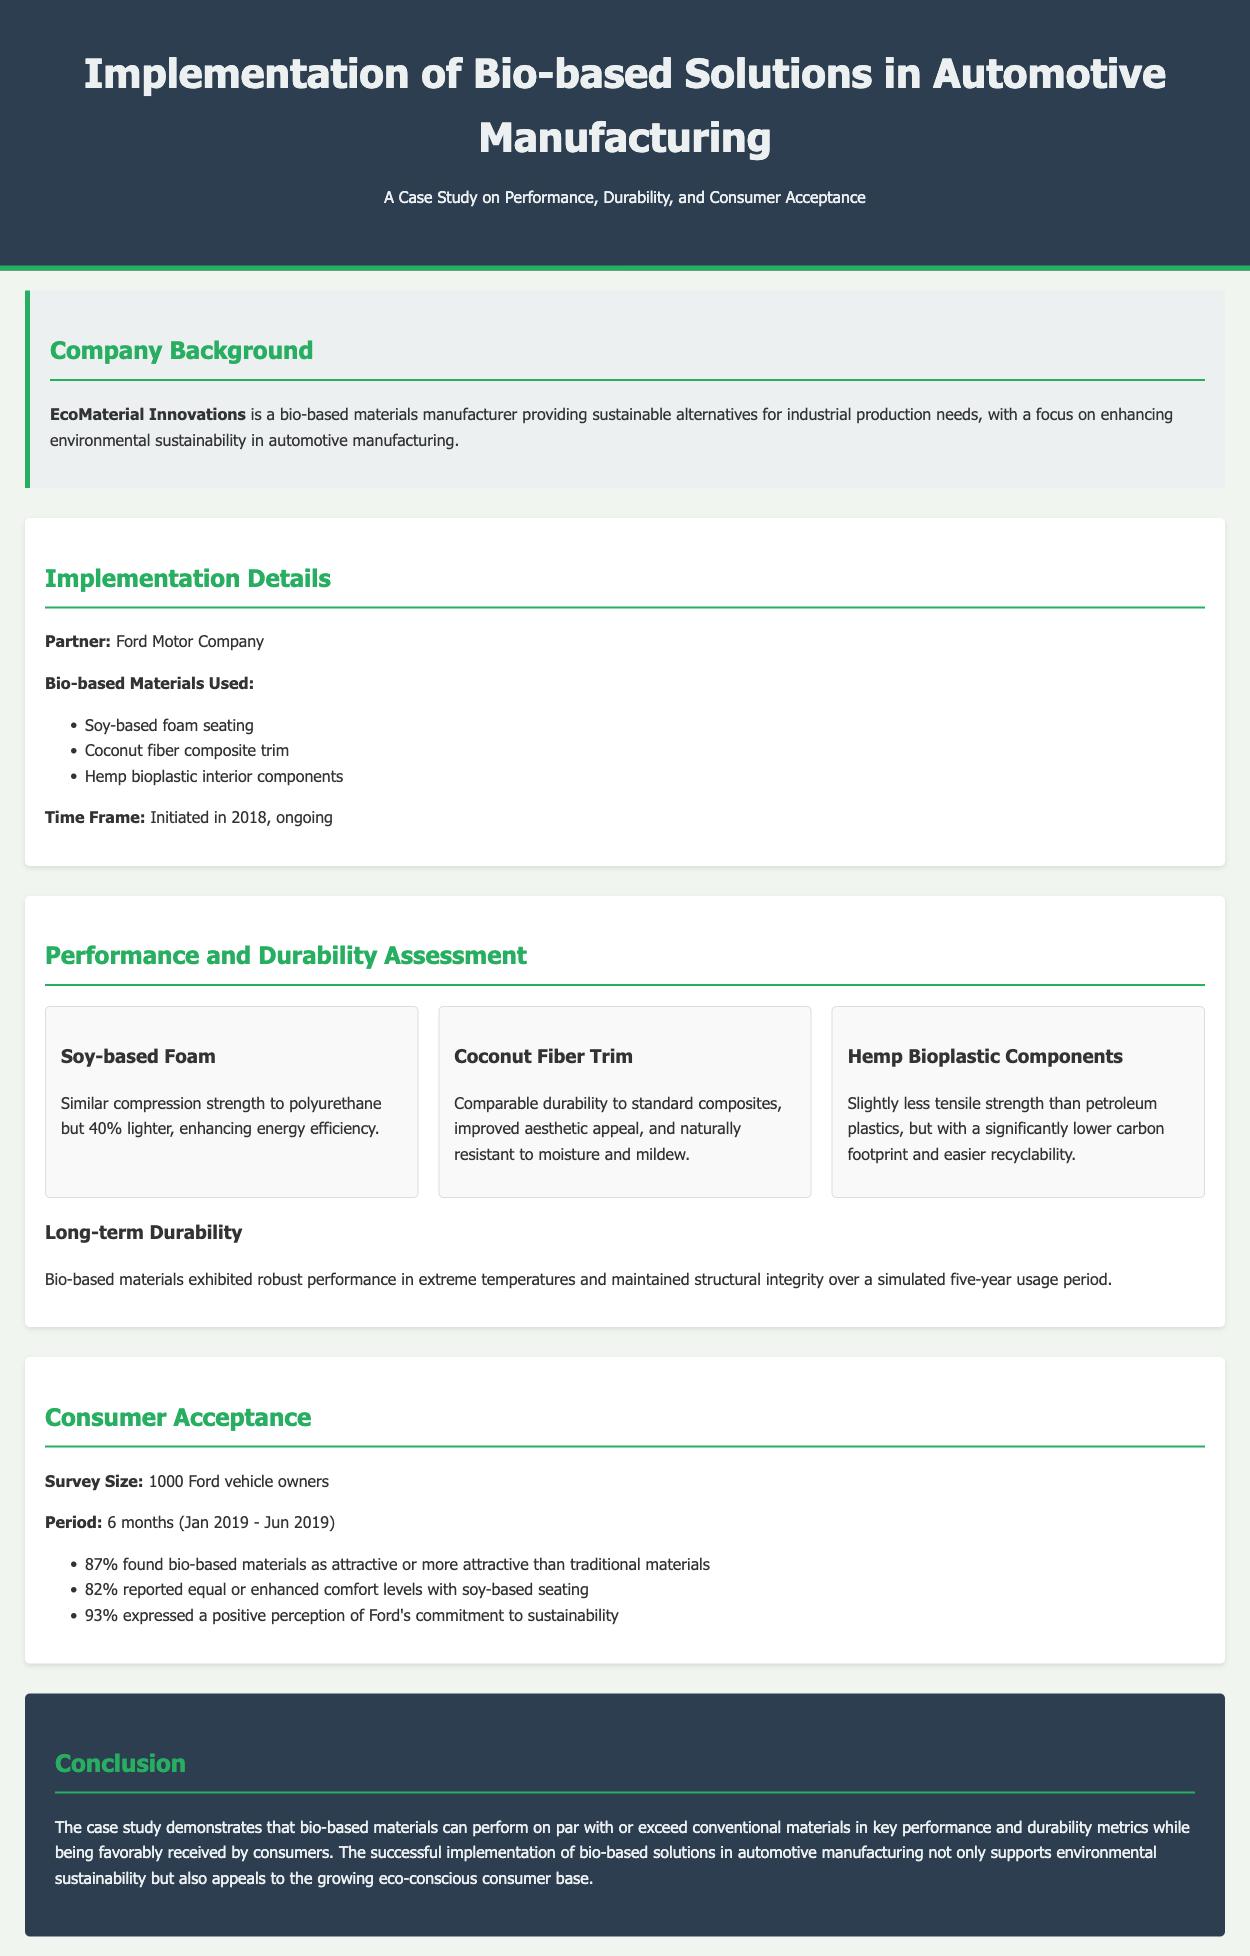What is the partner company for the bio-based materials project? The document specifies that EcoMaterial Innovations partnered with Ford Motor Company for the implementation of bio-based materials.
Answer: Ford Motor Company What are the bio-based materials used in the project? The case study lists three specific bio-based materials used: soy-based foam seating, coconut fiber composite trim, and hemp bioplastic interior components.
Answer: Soy-based foam seating, coconut fiber composite trim, hemp bioplastic interior components What percentage of consumers found bio-based materials attractive? The survey results show that 87% of Ford vehicle owners found bio-based materials attractive or more attractive than traditional materials.
Answer: 87% What was the period during which consumer acceptance was surveyed? The document states that the survey of consumer acceptance occurred over a period of six months, specifically from January 2019 to June 2019.
Answer: 6 months How does the tensile strength of hemp bioplastic compare to petroleum plastics? The document notes that hemp bioplastic has slightly less tensile strength than petroleum plastics.
Answer: Slightly less What is the time frame for the implementation of the bio-based materials? According to the case study, the implementation was initiated in 2018 and is ongoing.
Answer: Initiated in 2018, ongoing What percentage of respondents reported equal or enhanced comfort levels with soy-based seating? The case study indicates that 82% of respondents reported equal or enhanced comfort levels with soy-based seating.
Answer: 82% What aspect of the bio-based materials was highlighted in terms of long-term performance? The document emphasizes that bio-based materials maintained structural integrity over a simulated five-year usage period, showing robust performance.
Answer: Maintained structural integrity over a simulated five-year usage period 